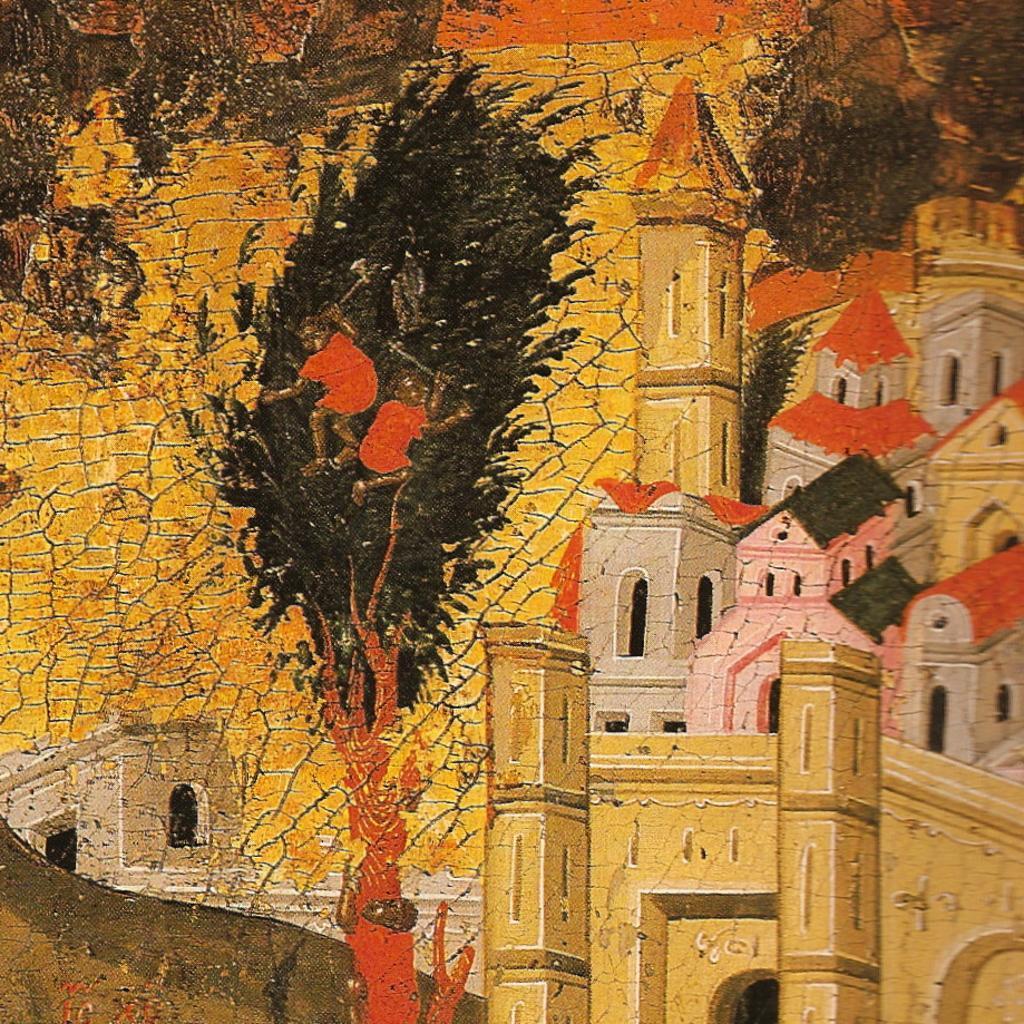In one or two sentences, can you explain what this image depicts? This is a painting and in this painting we can see buildings,trees. 